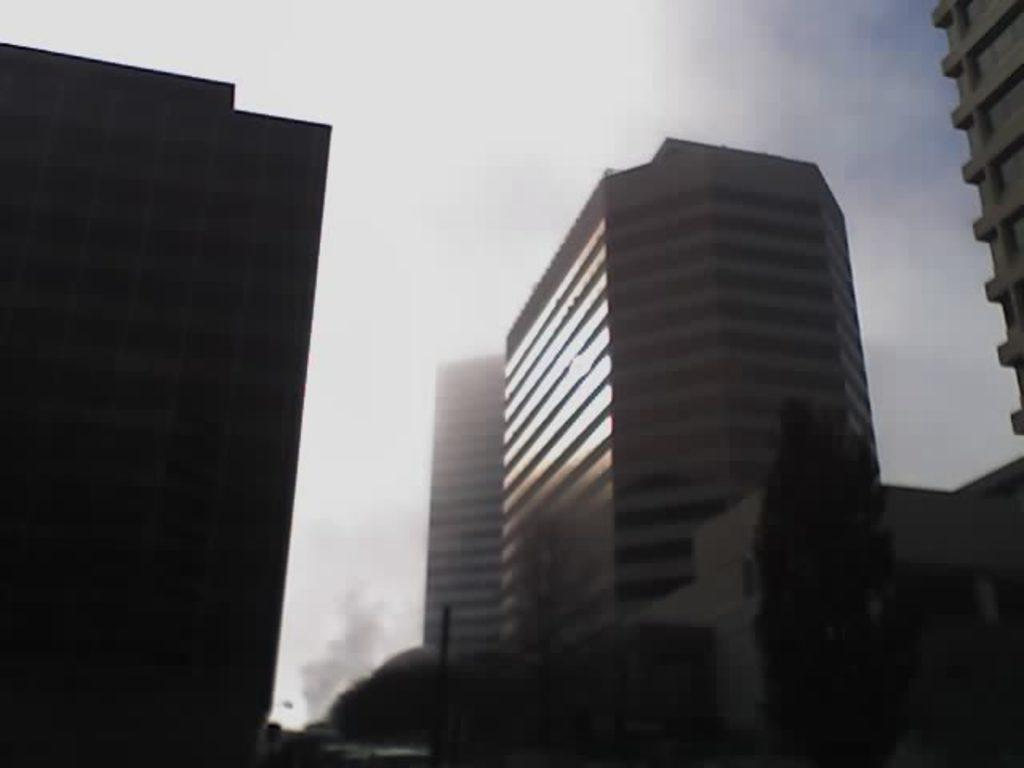What is located in the center of the image? There are buildings and trees in the center of the image. Can you describe the background of the image? The sky is visible in the background of the image. Where is the crate being carried by the porter in the image? There is no crate or porter present in the image. What advice might the uncle give to someone in the image? There is no uncle present in the image, so it is not possible to determine what advice he might give. 